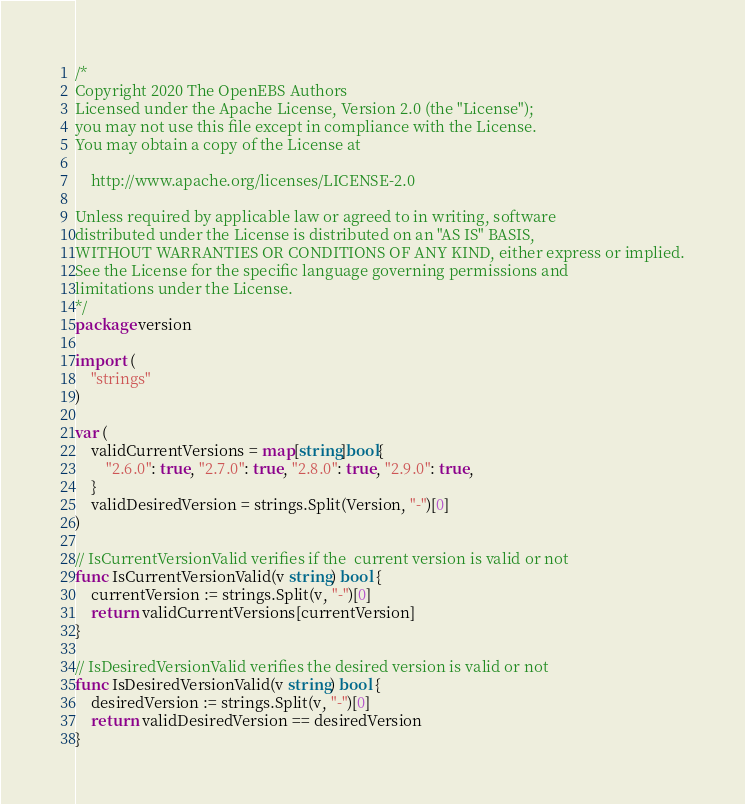<code> <loc_0><loc_0><loc_500><loc_500><_Go_>/*
Copyright 2020 The OpenEBS Authors
Licensed under the Apache License, Version 2.0 (the "License");
you may not use this file except in compliance with the License.
You may obtain a copy of the License at

	http://www.apache.org/licenses/LICENSE-2.0

Unless required by applicable law or agreed to in writing, software
distributed under the License is distributed on an "AS IS" BASIS,
WITHOUT WARRANTIES OR CONDITIONS OF ANY KIND, either express or implied.
See the License for the specific language governing permissions and
limitations under the License.
*/
package version

import (
	"strings"
)

var (
	validCurrentVersions = map[string]bool{
		"2.6.0": true, "2.7.0": true, "2.8.0": true, "2.9.0": true,
	}
	validDesiredVersion = strings.Split(Version, "-")[0]
)

// IsCurrentVersionValid verifies if the  current version is valid or not
func IsCurrentVersionValid(v string) bool {
	currentVersion := strings.Split(v, "-")[0]
	return validCurrentVersions[currentVersion]
}

// IsDesiredVersionValid verifies the desired version is valid or not
func IsDesiredVersionValid(v string) bool {
	desiredVersion := strings.Split(v, "-")[0]
	return validDesiredVersion == desiredVersion
}
</code> 